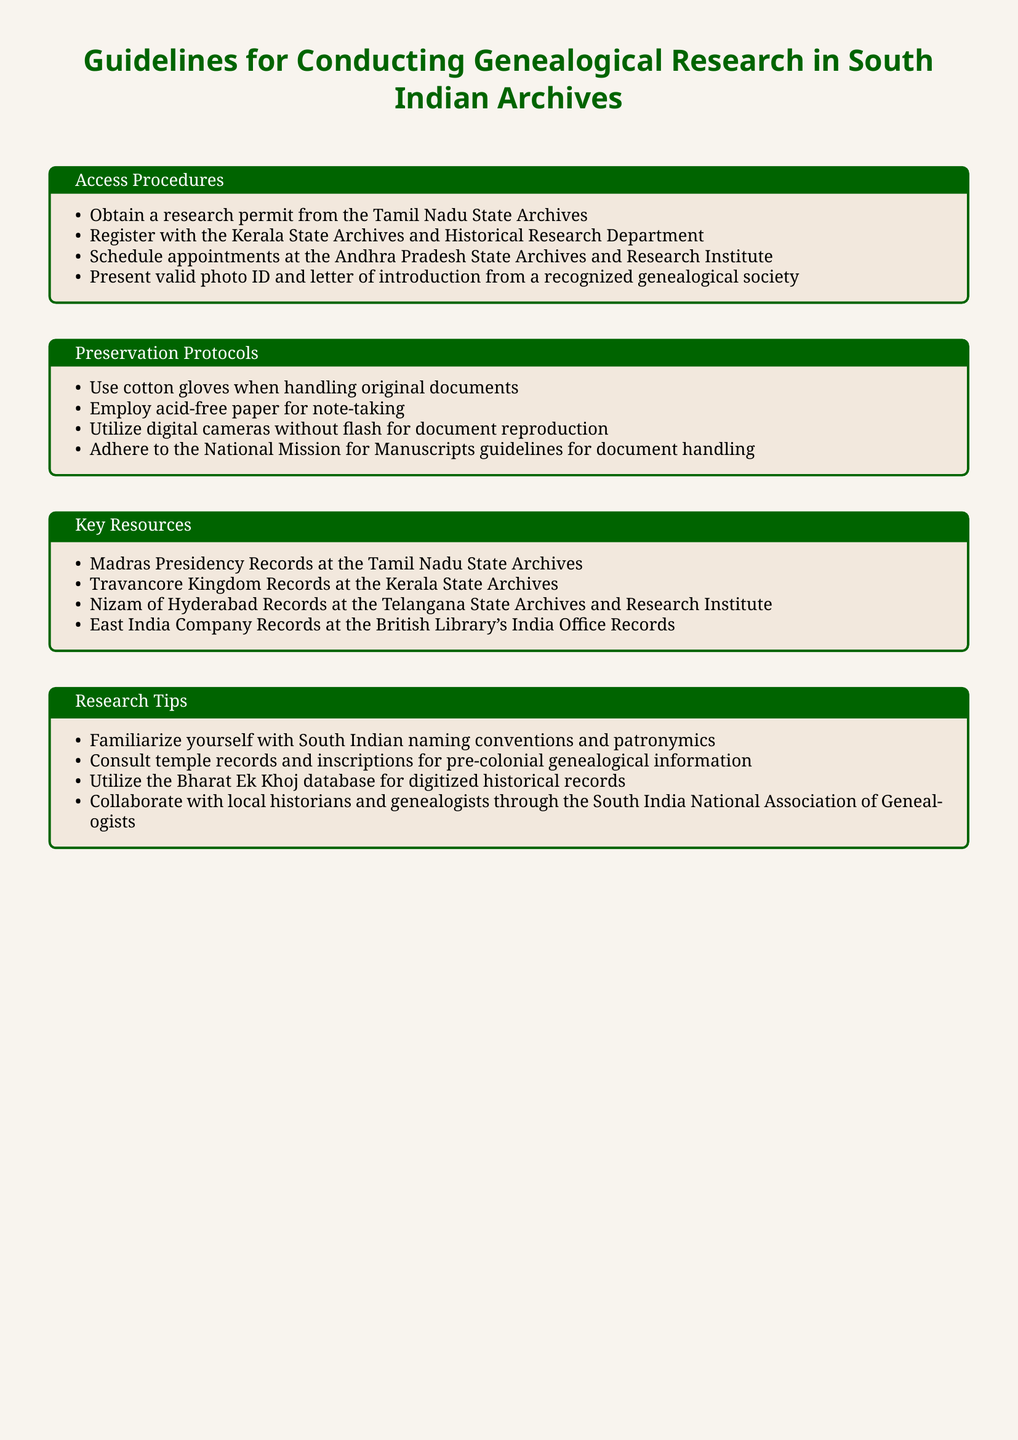What is required to access Tamil Nadu State Archives? A research permit is needed to access Tamil Nadu State Archives.
Answer: research permit What document must researchers present at the Andhra Pradesh State Archives? Researchers must present a valid photo ID and a letter of introduction from a recognized genealogical society.
Answer: valid photo ID and letter of introduction Which type of paper should be used for note-taking? Researchers should use acid-free paper for note-taking to ensure document preservation.
Answer: acid-free paper What is one of the key records available at the Kerala State Archives? The Travancore Kingdom Records are one of the key records available at the Kerala State Archives.
Answer: Travancore Kingdom Records Which database is recommended for digitized historical records? The Bharat Ek Khoj database is recommended for accessing digitized historical records.
Answer: Bharat Ek Khoj database What is the primary purpose of utilizing cotton gloves? The primary purpose of using cotton gloves is to handle original documents safely and avoid damage.
Answer: handle original documents How should researchers document reproduction of archives? Researchers should utilize digital cameras without flash for document reproduction.
Answer: digital cameras without flash What is the title of this document? The title of this document is "Guidelines for Conducting Genealogical Research in South Indian Archives."
Answer: Guidelines for Conducting Genealogical Research in South Indian Archives Which association can researchers collaborate with for guidance? Researchers can collaborate with the South India National Association of Genealogists for guidance.
Answer: South India National Association of Genealogists 